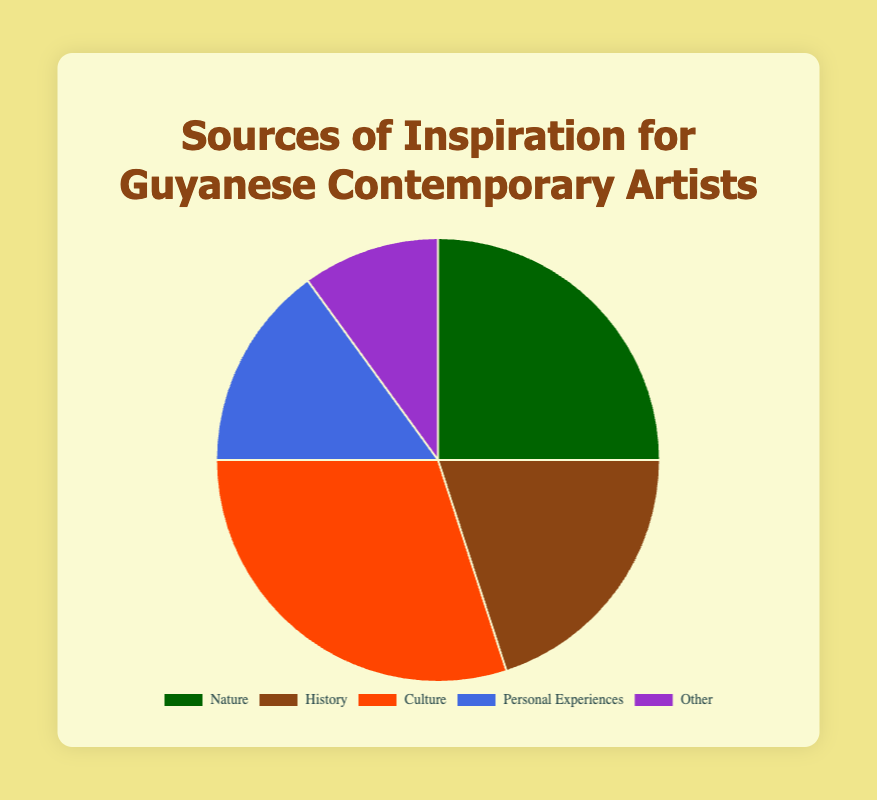What is the largest source of inspiration for Guyanese contemporary artists? The pie chart shows that the largest segment is for the category “Culture”, which occupies 30% of the chart.
Answer: Culture How much more does Culture contribute compared to Nature? Culture contributes 30% while Nature contributes 25%. The difference is calculated as 30% - 25% = 5%.
Answer: 5% Which category is represented by the green color? The green color section in the pie chart corresponds to the category labeled "Nature."
Answer: Nature If we combine the percentages of History and Personal Experiences, what is the total contribution to sources of inspiration? History accounts for 20% and Personal Experiences account for 15%. Adding the two gives 20% + 15% = 35%.
Answer: 35% Which two categories together make up half of the sources of inspiration? Nature contributes 25% and Culture contributes 30%. Combined, this is 25% + 30% = 55%, covering more than half. Thus, checking the next combination of Culture and another significant category, we find Culture (30%) and History (20%) combined is 30% + 20% = 50%.
Answer: Culture and History Which category has the lowest contribution to sources of inspiration? The smallest section of the pie chart represents the "Other" category, contributing 10%.
Answer: Other How much greater is the percentage of Nature compared to Personal Experiences? Nature contributes 25% and Personal Experiences contribute 15%. The difference is 25% - 15% = 10%.
Answer: 10% Is the combined contribution of Personal Experiences and Other greater or lesser than Culture? Personal Experiences contribute 15% and Other contributes 10%. Their combined contribution is 15% + 10% = 25%, which is less than Culture’s 30%.
Answer: Lesser What color represents the History category in the pie chart? The History category is represented by brown color in the pie chart.
Answer: Brown 